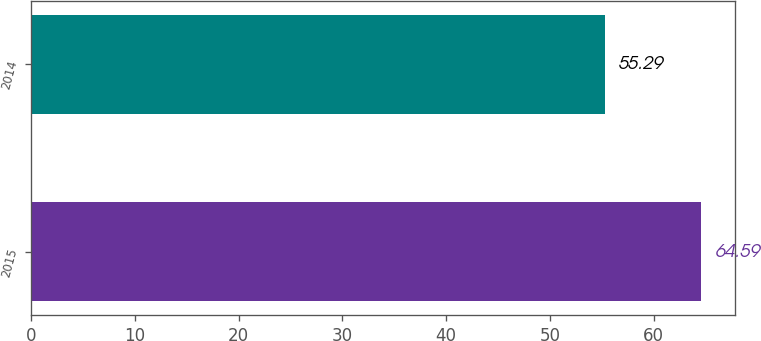Convert chart to OTSL. <chart><loc_0><loc_0><loc_500><loc_500><bar_chart><fcel>2015<fcel>2014<nl><fcel>64.59<fcel>55.29<nl></chart> 